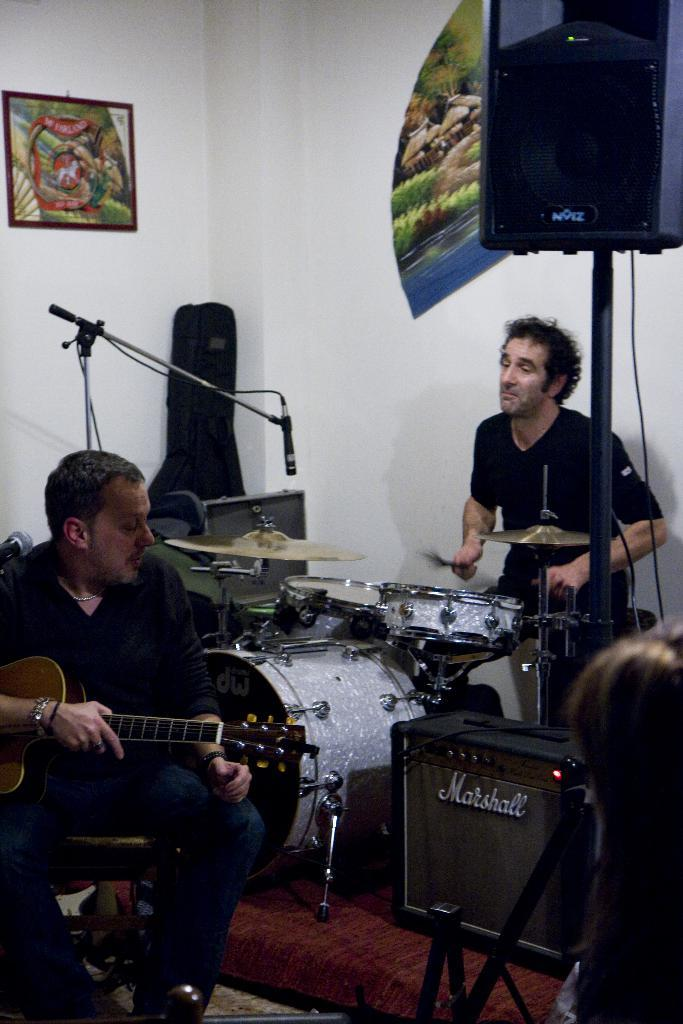How many people are in the image? There are two persons in the image. What are the two persons doing? One person is playing a guitar, and the other person is playing drums. What object is in front of the two persons? There is a microphone in front of them. What can be seen in the background of the image? There is a guitar bag, frames on the wall, and speakers in the background. What type of belief is being discussed in the image? There is no discussion of beliefs in the image; it features two people playing musical instruments. Can you see a cave in the background of the image? No, there is no cave present in the image. 